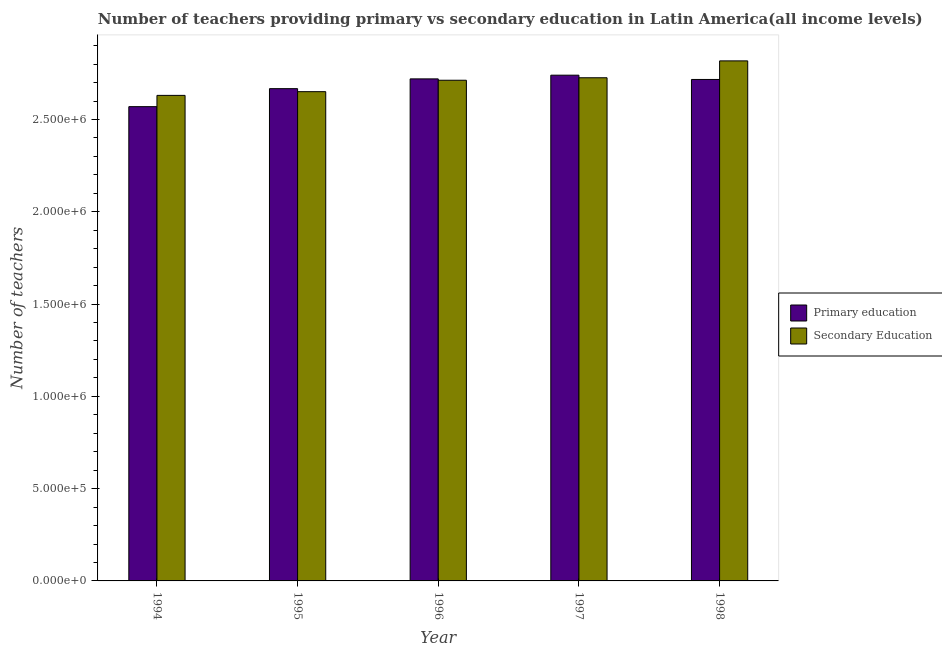Are the number of bars per tick equal to the number of legend labels?
Provide a succinct answer. Yes. Are the number of bars on each tick of the X-axis equal?
Make the answer very short. Yes. How many bars are there on the 3rd tick from the right?
Offer a terse response. 2. In how many cases, is the number of bars for a given year not equal to the number of legend labels?
Your answer should be compact. 0. What is the number of secondary teachers in 1995?
Give a very brief answer. 2.65e+06. Across all years, what is the maximum number of primary teachers?
Provide a succinct answer. 2.74e+06. Across all years, what is the minimum number of secondary teachers?
Ensure brevity in your answer.  2.63e+06. In which year was the number of primary teachers minimum?
Your answer should be compact. 1994. What is the total number of primary teachers in the graph?
Your answer should be compact. 1.34e+07. What is the difference between the number of primary teachers in 1994 and that in 1998?
Keep it short and to the point. -1.47e+05. What is the difference between the number of secondary teachers in 1994 and the number of primary teachers in 1998?
Keep it short and to the point. -1.87e+05. What is the average number of primary teachers per year?
Your answer should be very brief. 2.68e+06. In the year 1995, what is the difference between the number of secondary teachers and number of primary teachers?
Your answer should be very brief. 0. What is the ratio of the number of secondary teachers in 1996 to that in 1998?
Your response must be concise. 0.96. Is the difference between the number of secondary teachers in 1996 and 1998 greater than the difference between the number of primary teachers in 1996 and 1998?
Your answer should be very brief. No. What is the difference between the highest and the second highest number of primary teachers?
Provide a succinct answer. 2.00e+04. What is the difference between the highest and the lowest number of primary teachers?
Keep it short and to the point. 1.70e+05. What does the 1st bar from the left in 1995 represents?
Offer a terse response. Primary education. What does the 2nd bar from the right in 1994 represents?
Give a very brief answer. Primary education. How many bars are there?
Your response must be concise. 10. Are all the bars in the graph horizontal?
Offer a terse response. No. Are the values on the major ticks of Y-axis written in scientific E-notation?
Your answer should be compact. Yes. Does the graph contain grids?
Provide a short and direct response. No. Where does the legend appear in the graph?
Ensure brevity in your answer.  Center right. How many legend labels are there?
Give a very brief answer. 2. What is the title of the graph?
Keep it short and to the point. Number of teachers providing primary vs secondary education in Latin America(all income levels). What is the label or title of the X-axis?
Your answer should be compact. Year. What is the label or title of the Y-axis?
Keep it short and to the point. Number of teachers. What is the Number of teachers in Primary education in 1994?
Your response must be concise. 2.57e+06. What is the Number of teachers in Secondary Education in 1994?
Keep it short and to the point. 2.63e+06. What is the Number of teachers of Primary education in 1995?
Ensure brevity in your answer.  2.67e+06. What is the Number of teachers in Secondary Education in 1995?
Make the answer very short. 2.65e+06. What is the Number of teachers in Primary education in 1996?
Give a very brief answer. 2.72e+06. What is the Number of teachers in Secondary Education in 1996?
Give a very brief answer. 2.71e+06. What is the Number of teachers of Primary education in 1997?
Keep it short and to the point. 2.74e+06. What is the Number of teachers in Secondary Education in 1997?
Make the answer very short. 2.73e+06. What is the Number of teachers of Primary education in 1998?
Offer a very short reply. 2.72e+06. What is the Number of teachers in Secondary Education in 1998?
Your response must be concise. 2.82e+06. Across all years, what is the maximum Number of teachers in Primary education?
Your answer should be very brief. 2.74e+06. Across all years, what is the maximum Number of teachers of Secondary Education?
Provide a short and direct response. 2.82e+06. Across all years, what is the minimum Number of teachers of Primary education?
Your answer should be compact. 2.57e+06. Across all years, what is the minimum Number of teachers in Secondary Education?
Offer a very short reply. 2.63e+06. What is the total Number of teachers in Primary education in the graph?
Your response must be concise. 1.34e+07. What is the total Number of teachers in Secondary Education in the graph?
Provide a succinct answer. 1.35e+07. What is the difference between the Number of teachers of Primary education in 1994 and that in 1995?
Offer a terse response. -9.75e+04. What is the difference between the Number of teachers in Secondary Education in 1994 and that in 1995?
Offer a very short reply. -2.01e+04. What is the difference between the Number of teachers in Primary education in 1994 and that in 1996?
Your answer should be very brief. -1.50e+05. What is the difference between the Number of teachers of Secondary Education in 1994 and that in 1996?
Offer a very short reply. -8.20e+04. What is the difference between the Number of teachers of Primary education in 1994 and that in 1997?
Make the answer very short. -1.70e+05. What is the difference between the Number of teachers of Secondary Education in 1994 and that in 1997?
Offer a terse response. -9.55e+04. What is the difference between the Number of teachers of Primary education in 1994 and that in 1998?
Give a very brief answer. -1.47e+05. What is the difference between the Number of teachers of Secondary Education in 1994 and that in 1998?
Your response must be concise. -1.87e+05. What is the difference between the Number of teachers of Primary education in 1995 and that in 1996?
Your answer should be very brief. -5.30e+04. What is the difference between the Number of teachers in Secondary Education in 1995 and that in 1996?
Keep it short and to the point. -6.19e+04. What is the difference between the Number of teachers of Primary education in 1995 and that in 1997?
Your answer should be compact. -7.30e+04. What is the difference between the Number of teachers in Secondary Education in 1995 and that in 1997?
Provide a short and direct response. -7.54e+04. What is the difference between the Number of teachers of Primary education in 1995 and that in 1998?
Ensure brevity in your answer.  -4.98e+04. What is the difference between the Number of teachers in Secondary Education in 1995 and that in 1998?
Offer a very short reply. -1.67e+05. What is the difference between the Number of teachers in Primary education in 1996 and that in 1997?
Offer a terse response. -2.00e+04. What is the difference between the Number of teachers in Secondary Education in 1996 and that in 1997?
Make the answer very short. -1.35e+04. What is the difference between the Number of teachers of Primary education in 1996 and that in 1998?
Provide a succinct answer. 3170. What is the difference between the Number of teachers in Secondary Education in 1996 and that in 1998?
Give a very brief answer. -1.05e+05. What is the difference between the Number of teachers in Primary education in 1997 and that in 1998?
Offer a very short reply. 2.32e+04. What is the difference between the Number of teachers of Secondary Education in 1997 and that in 1998?
Your response must be concise. -9.15e+04. What is the difference between the Number of teachers of Primary education in 1994 and the Number of teachers of Secondary Education in 1995?
Keep it short and to the point. -8.11e+04. What is the difference between the Number of teachers of Primary education in 1994 and the Number of teachers of Secondary Education in 1996?
Make the answer very short. -1.43e+05. What is the difference between the Number of teachers in Primary education in 1994 and the Number of teachers in Secondary Education in 1997?
Make the answer very short. -1.57e+05. What is the difference between the Number of teachers in Primary education in 1994 and the Number of teachers in Secondary Education in 1998?
Give a very brief answer. -2.48e+05. What is the difference between the Number of teachers in Primary education in 1995 and the Number of teachers in Secondary Education in 1996?
Make the answer very short. -4.55e+04. What is the difference between the Number of teachers in Primary education in 1995 and the Number of teachers in Secondary Education in 1997?
Make the answer very short. -5.90e+04. What is the difference between the Number of teachers in Primary education in 1995 and the Number of teachers in Secondary Education in 1998?
Your answer should be compact. -1.50e+05. What is the difference between the Number of teachers of Primary education in 1996 and the Number of teachers of Secondary Education in 1997?
Provide a succinct answer. -6052.75. What is the difference between the Number of teachers in Primary education in 1996 and the Number of teachers in Secondary Education in 1998?
Offer a very short reply. -9.75e+04. What is the difference between the Number of teachers of Primary education in 1997 and the Number of teachers of Secondary Education in 1998?
Offer a very short reply. -7.75e+04. What is the average Number of teachers of Primary education per year?
Keep it short and to the point. 2.68e+06. What is the average Number of teachers in Secondary Education per year?
Offer a terse response. 2.71e+06. In the year 1994, what is the difference between the Number of teachers of Primary education and Number of teachers of Secondary Education?
Give a very brief answer. -6.11e+04. In the year 1995, what is the difference between the Number of teachers of Primary education and Number of teachers of Secondary Education?
Your answer should be very brief. 1.64e+04. In the year 1996, what is the difference between the Number of teachers in Primary education and Number of teachers in Secondary Education?
Give a very brief answer. 7430.25. In the year 1997, what is the difference between the Number of teachers in Primary education and Number of teachers in Secondary Education?
Offer a very short reply. 1.39e+04. In the year 1998, what is the difference between the Number of teachers of Primary education and Number of teachers of Secondary Education?
Give a very brief answer. -1.01e+05. What is the ratio of the Number of teachers in Primary education in 1994 to that in 1995?
Your response must be concise. 0.96. What is the ratio of the Number of teachers of Secondary Education in 1994 to that in 1995?
Provide a succinct answer. 0.99. What is the ratio of the Number of teachers of Primary education in 1994 to that in 1996?
Ensure brevity in your answer.  0.94. What is the ratio of the Number of teachers in Secondary Education in 1994 to that in 1996?
Provide a short and direct response. 0.97. What is the ratio of the Number of teachers in Primary education in 1994 to that in 1997?
Give a very brief answer. 0.94. What is the ratio of the Number of teachers in Secondary Education in 1994 to that in 1997?
Ensure brevity in your answer.  0.96. What is the ratio of the Number of teachers in Primary education in 1994 to that in 1998?
Provide a short and direct response. 0.95. What is the ratio of the Number of teachers in Secondary Education in 1994 to that in 1998?
Provide a short and direct response. 0.93. What is the ratio of the Number of teachers of Primary education in 1995 to that in 1996?
Keep it short and to the point. 0.98. What is the ratio of the Number of teachers in Secondary Education in 1995 to that in 1996?
Your response must be concise. 0.98. What is the ratio of the Number of teachers in Primary education in 1995 to that in 1997?
Give a very brief answer. 0.97. What is the ratio of the Number of teachers of Secondary Education in 1995 to that in 1997?
Your response must be concise. 0.97. What is the ratio of the Number of teachers of Primary education in 1995 to that in 1998?
Make the answer very short. 0.98. What is the ratio of the Number of teachers of Secondary Education in 1995 to that in 1998?
Your answer should be compact. 0.94. What is the ratio of the Number of teachers in Secondary Education in 1996 to that in 1997?
Make the answer very short. 1. What is the ratio of the Number of teachers in Secondary Education in 1996 to that in 1998?
Ensure brevity in your answer.  0.96. What is the ratio of the Number of teachers in Primary education in 1997 to that in 1998?
Your answer should be compact. 1.01. What is the ratio of the Number of teachers of Secondary Education in 1997 to that in 1998?
Give a very brief answer. 0.97. What is the difference between the highest and the second highest Number of teachers of Primary education?
Ensure brevity in your answer.  2.00e+04. What is the difference between the highest and the second highest Number of teachers of Secondary Education?
Give a very brief answer. 9.15e+04. What is the difference between the highest and the lowest Number of teachers of Primary education?
Keep it short and to the point. 1.70e+05. What is the difference between the highest and the lowest Number of teachers in Secondary Education?
Your answer should be compact. 1.87e+05. 